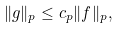<formula> <loc_0><loc_0><loc_500><loc_500>\| g \| _ { p } \leq c _ { p } \| f \| _ { p } ,</formula> 